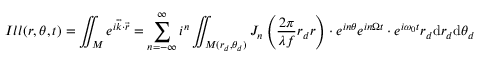Convert formula to latex. <formula><loc_0><loc_0><loc_500><loc_500>I l l ( r , \theta , t ) = \iint _ { M } e ^ { i \overrightarrow { k } \cdot \overrightarrow { r } } = \sum _ { n = - \infty } ^ { \infty } i ^ { n } \iint _ { M ( r _ { d } , \theta _ { d } ) } J _ { n } \left ( \frac { 2 \pi } { \lambda f } r _ { d } r \right ) \cdot e ^ { i n \theta } e ^ { i n \Omega t } \cdot e ^ { i \omega _ { 0 } t } r _ { d } d r _ { d } d \theta _ { d }</formula> 